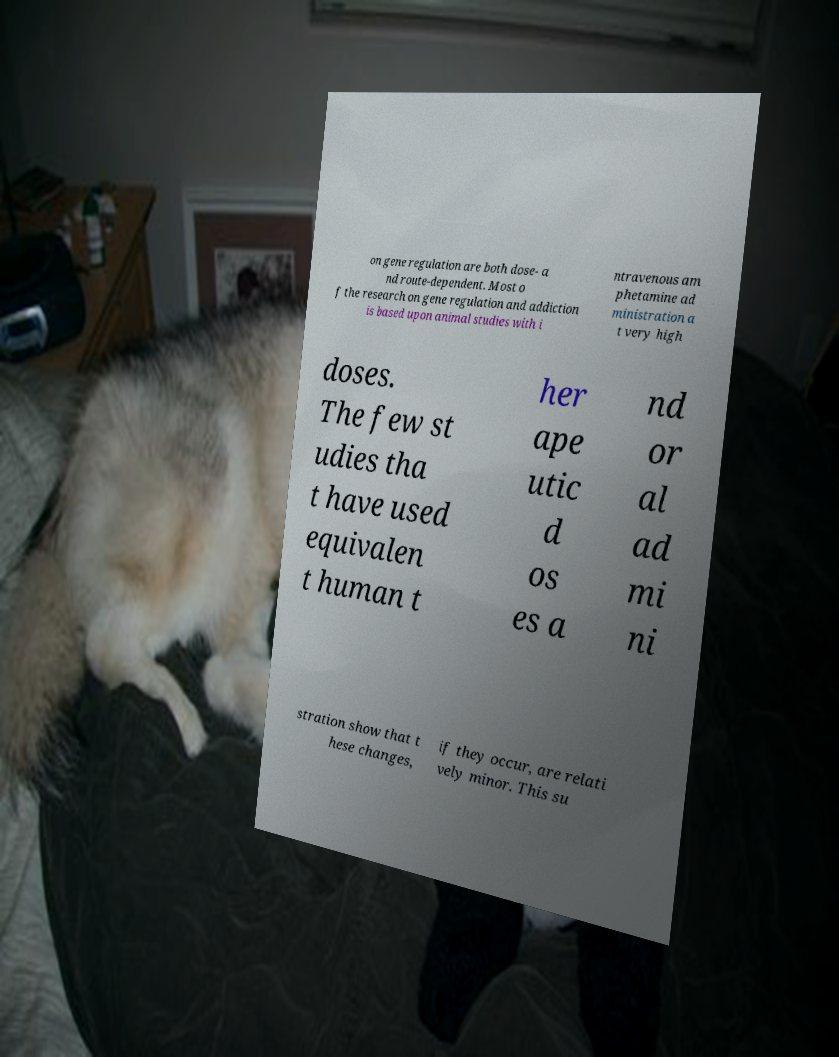Could you extract and type out the text from this image? on gene regulation are both dose- a nd route-dependent. Most o f the research on gene regulation and addiction is based upon animal studies with i ntravenous am phetamine ad ministration a t very high doses. The few st udies tha t have used equivalen t human t her ape utic d os es a nd or al ad mi ni stration show that t hese changes, if they occur, are relati vely minor. This su 